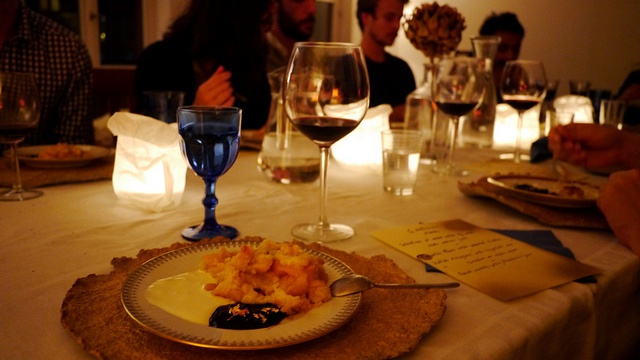Describe the objects in this image and their specific colors. I can see dining table in black, brown, maroon, and tan tones, people in black, maroon, and brown tones, people in black and maroon tones, wine glass in black, brown, maroon, and tan tones, and people in black, maroon, and brown tones in this image. 